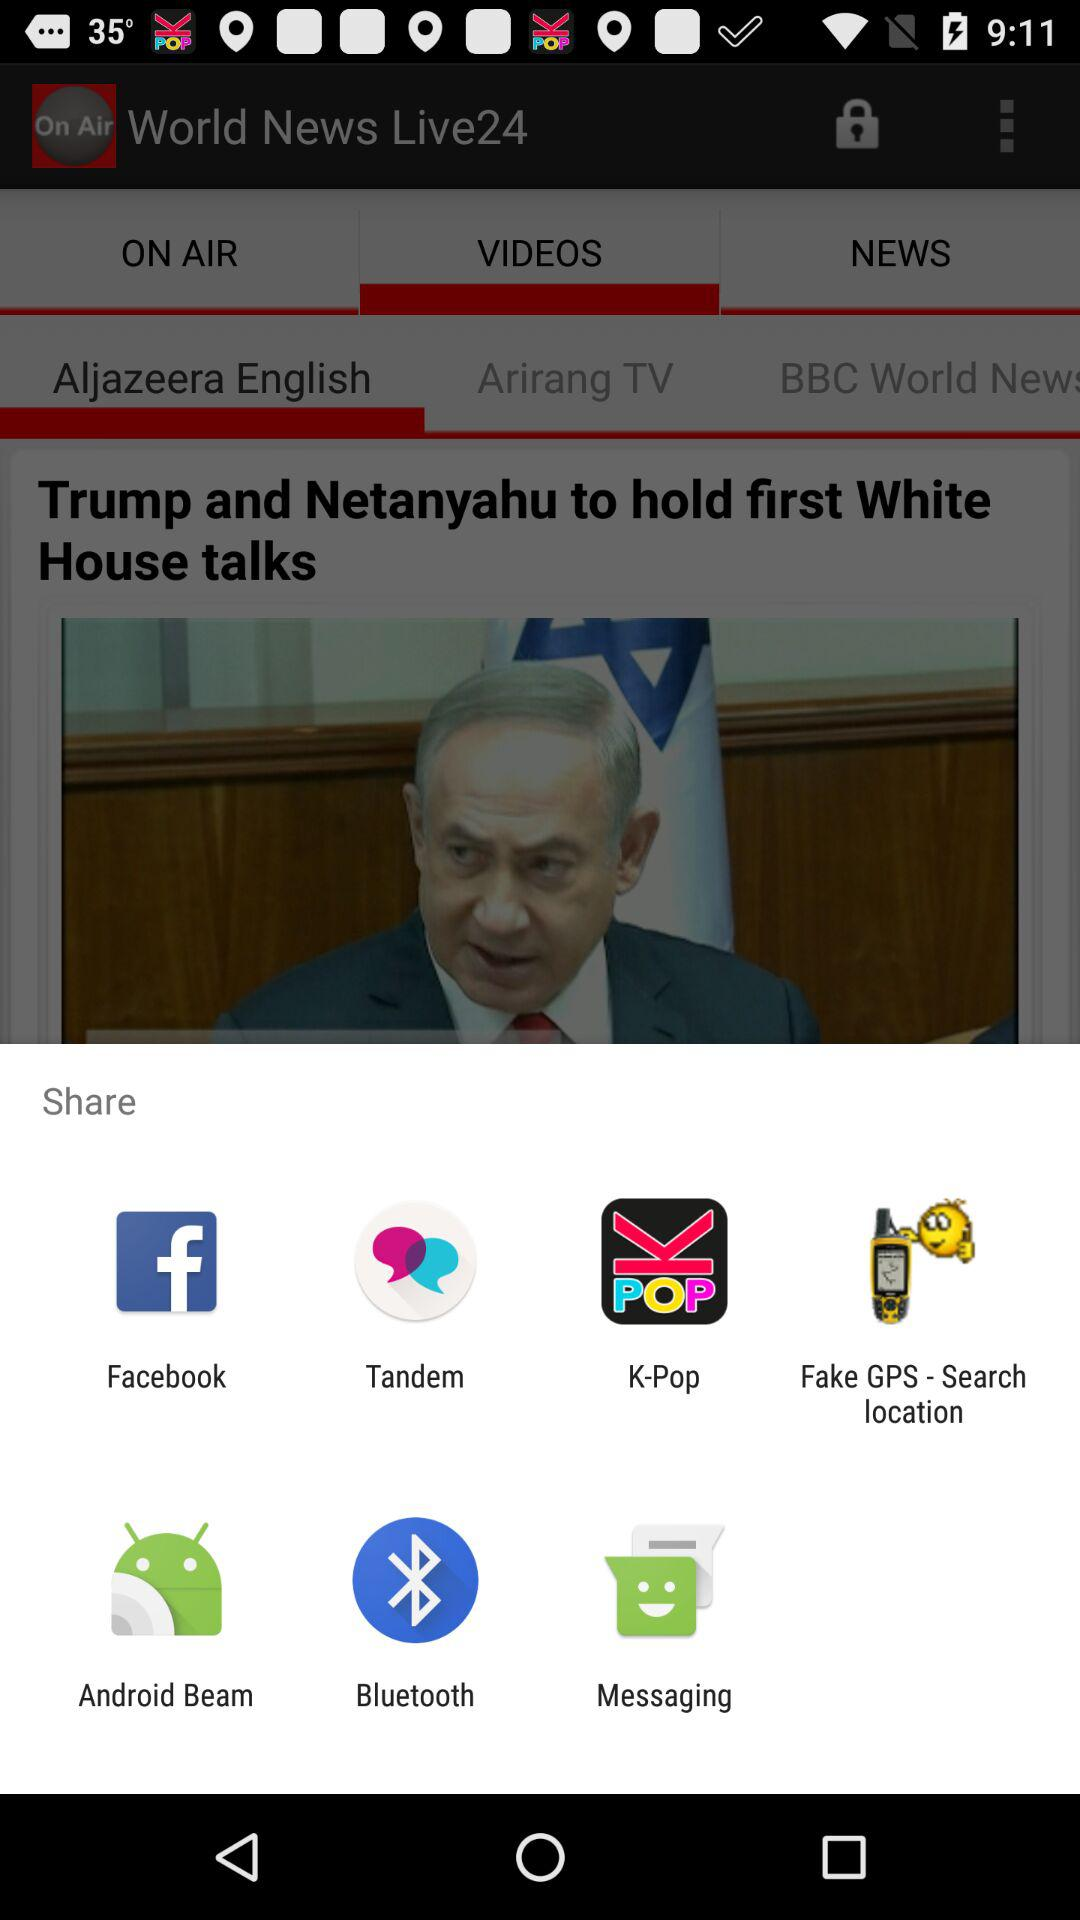What is the title of the content? The title of the content is "Trump and Netanyahu to hold first White House talks". 